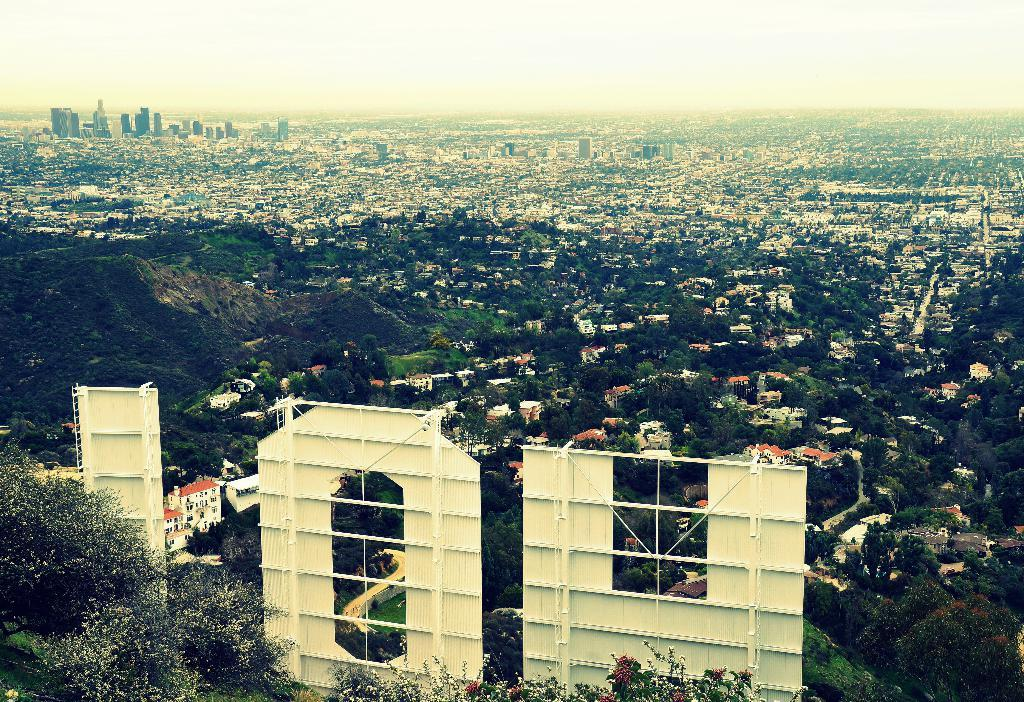What type of view is shown in the image? The image is a street view. What materials can be seen in the image? There are metal sheets in the image. What type of vegetation is present in the image? There are trees in the image. What type of structures are visible in the image? There are buildings in the image. What is visible in the background of the image? The sky is visible in the background of the image. What type of advertisement can be seen on the metal sheets in the image? There is no advertisement present on the metal sheets in the image. What role does the governor play in the image? There is no governor present in the image, so it is not possible to determine their role. 